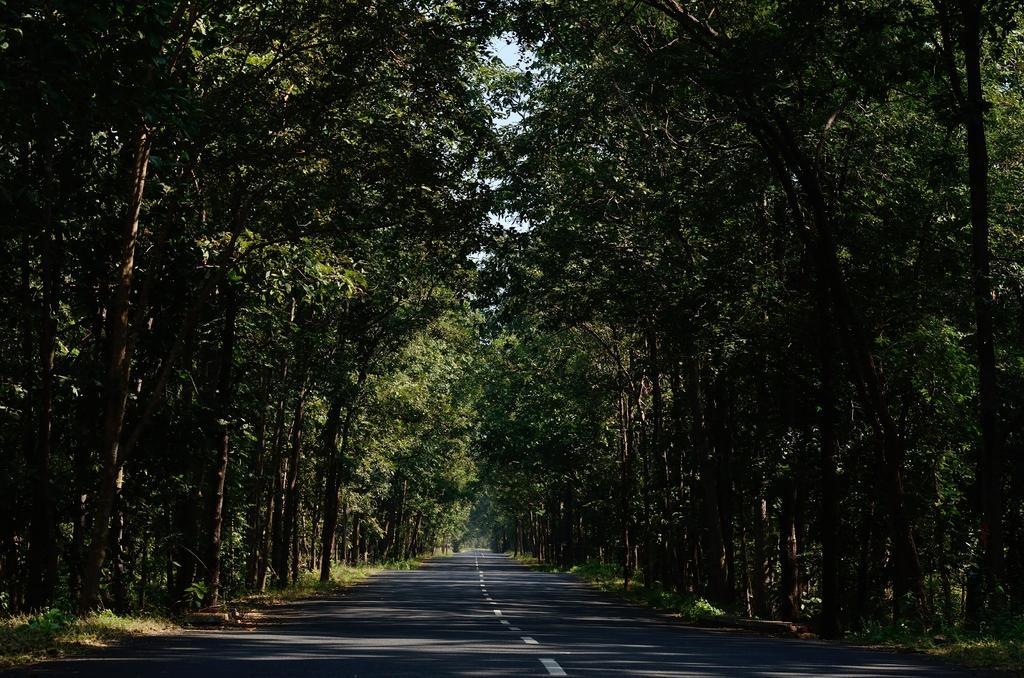Can you describe this image briefly? In this image, there are trees. At the bottom, there is a road. 